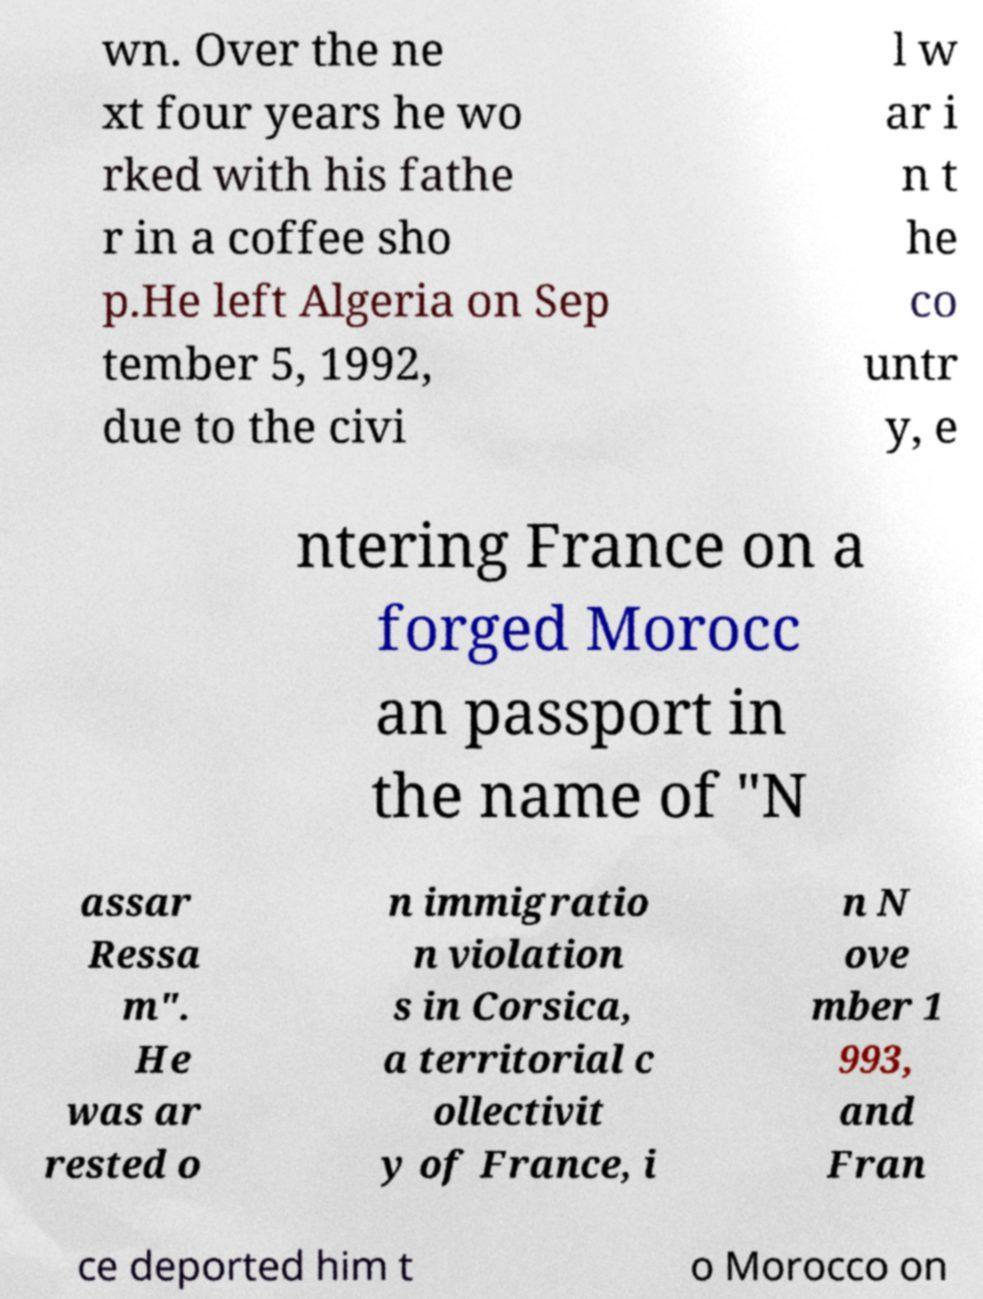Can you accurately transcribe the text from the provided image for me? wn. Over the ne xt four years he wo rked with his fathe r in a coffee sho p.He left Algeria on Sep tember 5, 1992, due to the civi l w ar i n t he co untr y, e ntering France on a forged Morocc an passport in the name of "N assar Ressa m". He was ar rested o n immigratio n violation s in Corsica, a territorial c ollectivit y of France, i n N ove mber 1 993, and Fran ce deported him t o Morocco on 